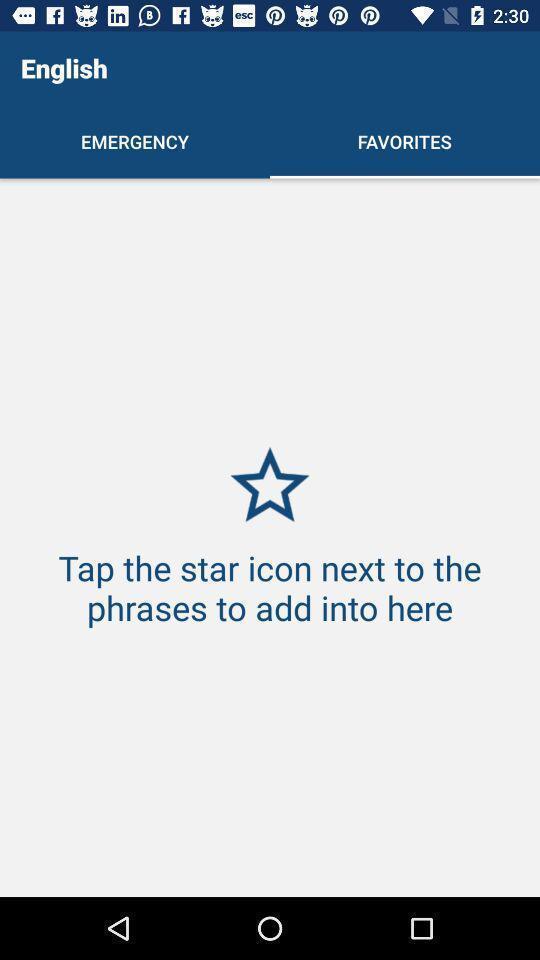Provide a textual representation of this image. Screen showing favorites page. 